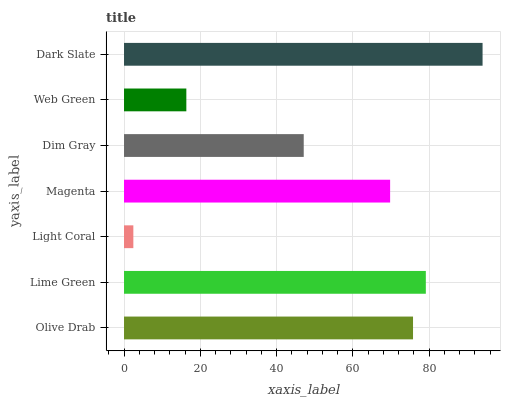Is Light Coral the minimum?
Answer yes or no. Yes. Is Dark Slate the maximum?
Answer yes or no. Yes. Is Lime Green the minimum?
Answer yes or no. No. Is Lime Green the maximum?
Answer yes or no. No. Is Lime Green greater than Olive Drab?
Answer yes or no. Yes. Is Olive Drab less than Lime Green?
Answer yes or no. Yes. Is Olive Drab greater than Lime Green?
Answer yes or no. No. Is Lime Green less than Olive Drab?
Answer yes or no. No. Is Magenta the high median?
Answer yes or no. Yes. Is Magenta the low median?
Answer yes or no. Yes. Is Lime Green the high median?
Answer yes or no. No. Is Dark Slate the low median?
Answer yes or no. No. 